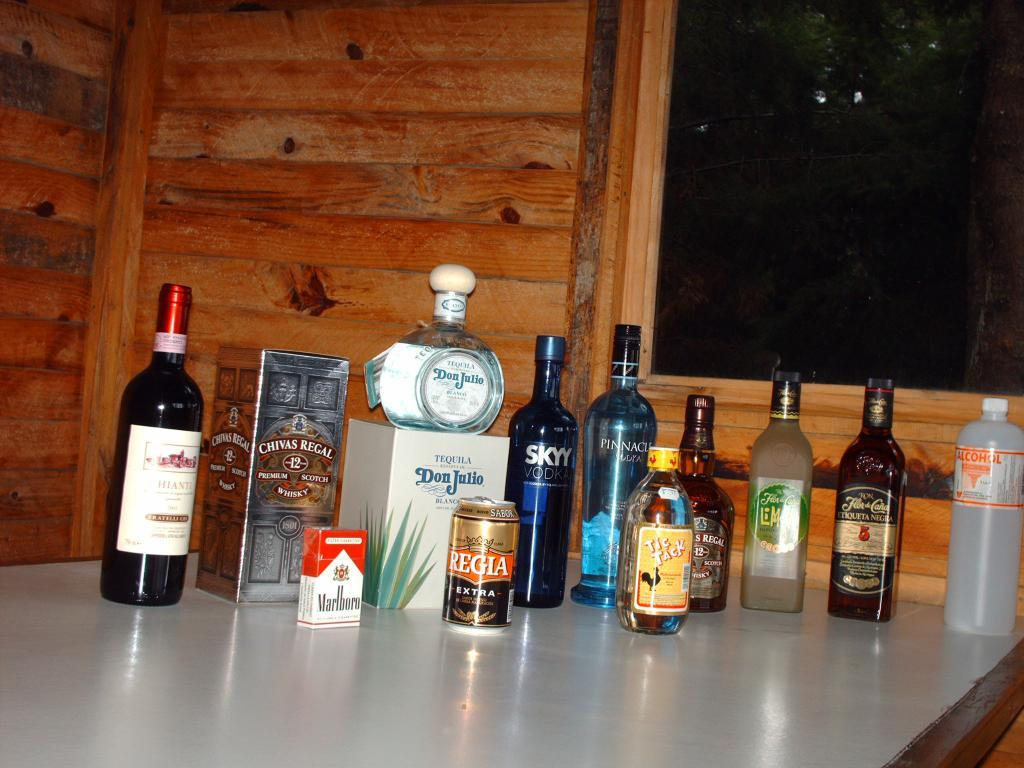What objects are on the table in the image? There are bottles on the table in the image. What can be seen in the background of the image? There is a wooden wall in the background. Where is the window located in the image? The window is on the right side of the image. What type of hole can be seen in the image? There is no hole present in the image. What is the grandmother doing in the image? There is no grandmother present in the image. 